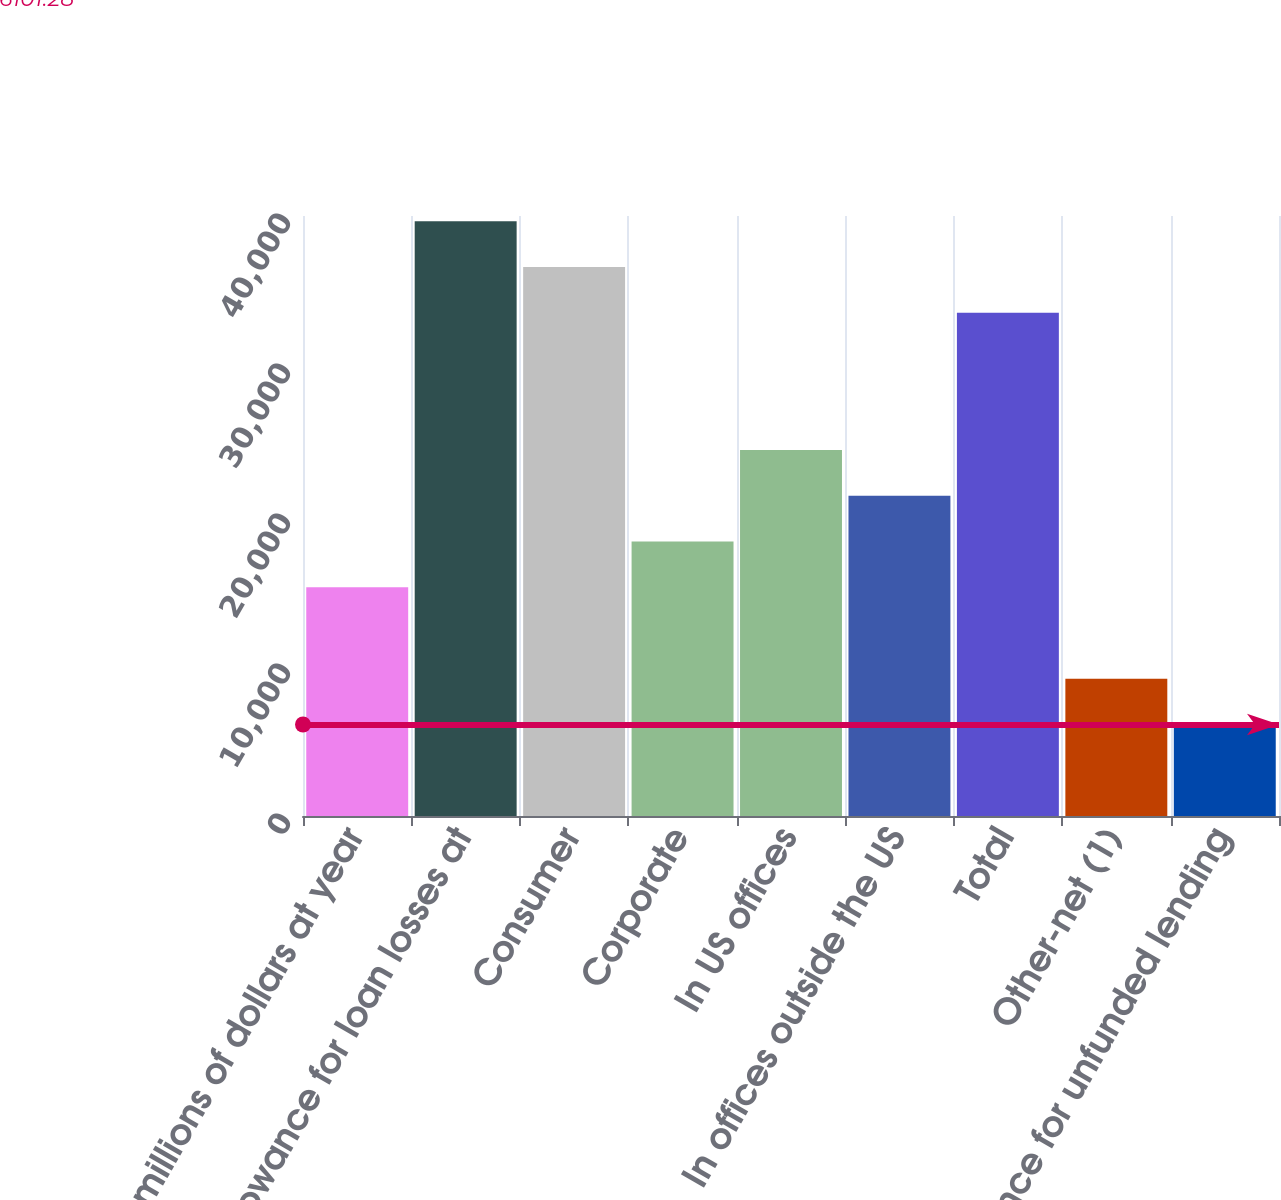Convert chart to OTSL. <chart><loc_0><loc_0><loc_500><loc_500><bar_chart><fcel>In millions of dollars at year<fcel>Allowance for loan losses at<fcel>Consumer<fcel>Corporate<fcel>In US offices<fcel>In offices outside the US<fcel>Total<fcel>Other-net (1)<fcel>Allowance for unfunded lending<nl><fcel>15251.9<fcel>39653.7<fcel>36603.5<fcel>18302.2<fcel>24402.6<fcel>21352.4<fcel>33553.3<fcel>9151.5<fcel>6101.28<nl></chart> 